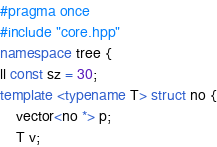Convert code to text. <code><loc_0><loc_0><loc_500><loc_500><_C++_>#pragma once
#include "core.hpp"
namespace tree {
ll const sz = 30;
template <typename T> struct no {
	vector<no *> p;
	T v;</code> 